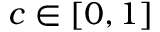Convert formula to latex. <formula><loc_0><loc_0><loc_500><loc_500>c \in [ 0 , 1 ]</formula> 